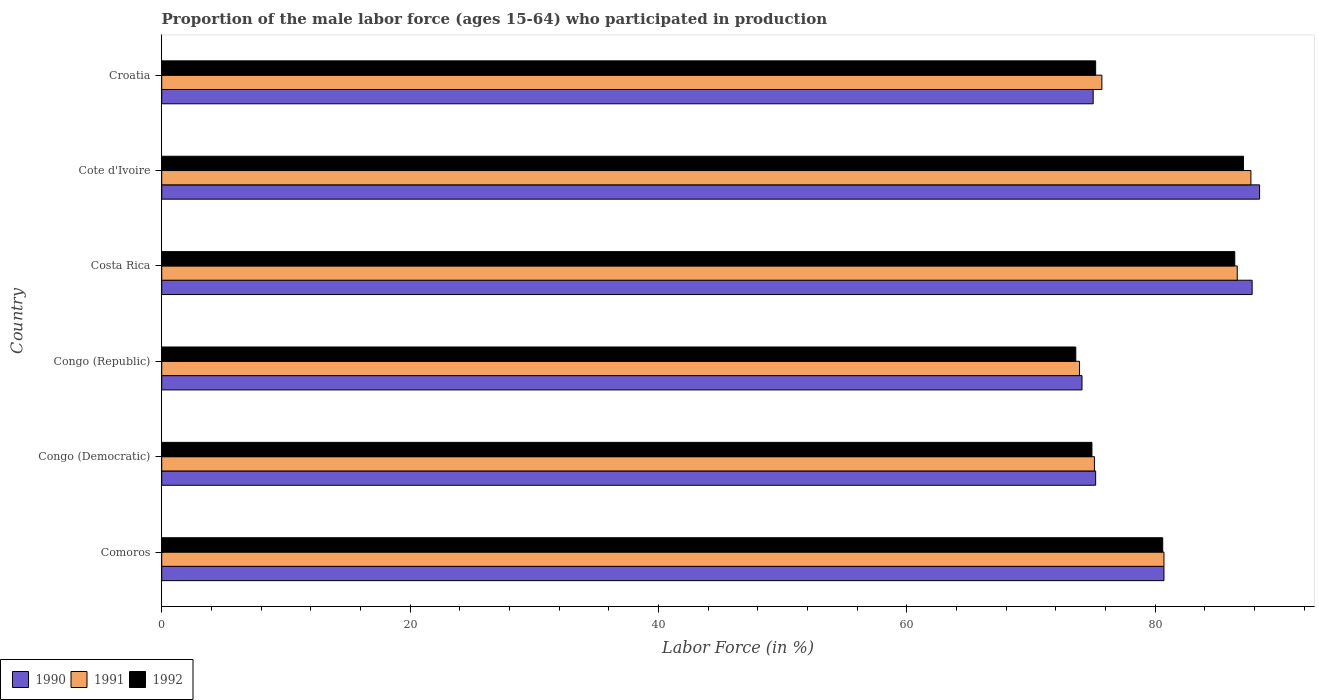How many different coloured bars are there?
Provide a short and direct response. 3. Are the number of bars per tick equal to the number of legend labels?
Provide a short and direct response. Yes. Are the number of bars on each tick of the Y-axis equal?
Give a very brief answer. Yes. How many bars are there on the 3rd tick from the bottom?
Give a very brief answer. 3. What is the label of the 1st group of bars from the top?
Provide a succinct answer. Croatia. What is the proportion of the male labor force who participated in production in 1990 in Costa Rica?
Offer a terse response. 87.8. Across all countries, what is the maximum proportion of the male labor force who participated in production in 1992?
Provide a succinct answer. 87.1. Across all countries, what is the minimum proportion of the male labor force who participated in production in 1991?
Make the answer very short. 73.9. In which country was the proportion of the male labor force who participated in production in 1991 maximum?
Ensure brevity in your answer.  Cote d'Ivoire. In which country was the proportion of the male labor force who participated in production in 1990 minimum?
Keep it short and to the point. Congo (Republic). What is the total proportion of the male labor force who participated in production in 1991 in the graph?
Ensure brevity in your answer.  479.7. What is the average proportion of the male labor force who participated in production in 1992 per country?
Your answer should be compact. 79.63. What is the difference between the proportion of the male labor force who participated in production in 1990 and proportion of the male labor force who participated in production in 1992 in Comoros?
Offer a terse response. 0.1. What is the ratio of the proportion of the male labor force who participated in production in 1992 in Congo (Democratic) to that in Croatia?
Ensure brevity in your answer.  1. Is the proportion of the male labor force who participated in production in 1992 in Congo (Democratic) less than that in Croatia?
Provide a succinct answer. Yes. Is the difference between the proportion of the male labor force who participated in production in 1990 in Cote d'Ivoire and Croatia greater than the difference between the proportion of the male labor force who participated in production in 1992 in Cote d'Ivoire and Croatia?
Your response must be concise. Yes. What is the difference between the highest and the second highest proportion of the male labor force who participated in production in 1992?
Your response must be concise. 0.7. What is the difference between the highest and the lowest proportion of the male labor force who participated in production in 1991?
Ensure brevity in your answer.  13.8. In how many countries, is the proportion of the male labor force who participated in production in 1991 greater than the average proportion of the male labor force who participated in production in 1991 taken over all countries?
Your answer should be compact. 3. Is the sum of the proportion of the male labor force who participated in production in 1992 in Comoros and Cote d'Ivoire greater than the maximum proportion of the male labor force who participated in production in 1991 across all countries?
Make the answer very short. Yes. How many bars are there?
Provide a short and direct response. 18. Are all the bars in the graph horizontal?
Offer a terse response. Yes. How many countries are there in the graph?
Give a very brief answer. 6. What is the difference between two consecutive major ticks on the X-axis?
Your answer should be compact. 20. Does the graph contain any zero values?
Keep it short and to the point. No. Where does the legend appear in the graph?
Offer a terse response. Bottom left. How many legend labels are there?
Give a very brief answer. 3. How are the legend labels stacked?
Provide a short and direct response. Horizontal. What is the title of the graph?
Ensure brevity in your answer.  Proportion of the male labor force (ages 15-64) who participated in production. What is the label or title of the X-axis?
Your answer should be compact. Labor Force (in %). What is the label or title of the Y-axis?
Your answer should be compact. Country. What is the Labor Force (in %) in 1990 in Comoros?
Provide a short and direct response. 80.7. What is the Labor Force (in %) of 1991 in Comoros?
Give a very brief answer. 80.7. What is the Labor Force (in %) in 1992 in Comoros?
Provide a short and direct response. 80.6. What is the Labor Force (in %) of 1990 in Congo (Democratic)?
Provide a succinct answer. 75.2. What is the Labor Force (in %) in 1991 in Congo (Democratic)?
Offer a terse response. 75.1. What is the Labor Force (in %) in 1992 in Congo (Democratic)?
Keep it short and to the point. 74.9. What is the Labor Force (in %) in 1990 in Congo (Republic)?
Your answer should be compact. 74.1. What is the Labor Force (in %) in 1991 in Congo (Republic)?
Keep it short and to the point. 73.9. What is the Labor Force (in %) in 1992 in Congo (Republic)?
Your response must be concise. 73.6. What is the Labor Force (in %) in 1990 in Costa Rica?
Your answer should be very brief. 87.8. What is the Labor Force (in %) in 1991 in Costa Rica?
Offer a terse response. 86.6. What is the Labor Force (in %) of 1992 in Costa Rica?
Offer a very short reply. 86.4. What is the Labor Force (in %) of 1990 in Cote d'Ivoire?
Keep it short and to the point. 88.4. What is the Labor Force (in %) in 1991 in Cote d'Ivoire?
Make the answer very short. 87.7. What is the Labor Force (in %) in 1992 in Cote d'Ivoire?
Your answer should be very brief. 87.1. What is the Labor Force (in %) of 1991 in Croatia?
Your answer should be compact. 75.7. What is the Labor Force (in %) of 1992 in Croatia?
Provide a short and direct response. 75.2. Across all countries, what is the maximum Labor Force (in %) of 1990?
Give a very brief answer. 88.4. Across all countries, what is the maximum Labor Force (in %) of 1991?
Offer a very short reply. 87.7. Across all countries, what is the maximum Labor Force (in %) in 1992?
Provide a short and direct response. 87.1. Across all countries, what is the minimum Labor Force (in %) of 1990?
Provide a short and direct response. 74.1. Across all countries, what is the minimum Labor Force (in %) of 1991?
Your response must be concise. 73.9. Across all countries, what is the minimum Labor Force (in %) of 1992?
Your response must be concise. 73.6. What is the total Labor Force (in %) of 1990 in the graph?
Make the answer very short. 481.2. What is the total Labor Force (in %) in 1991 in the graph?
Offer a terse response. 479.7. What is the total Labor Force (in %) of 1992 in the graph?
Give a very brief answer. 477.8. What is the difference between the Labor Force (in %) in 1992 in Comoros and that in Congo (Democratic)?
Offer a terse response. 5.7. What is the difference between the Labor Force (in %) in 1990 in Comoros and that in Congo (Republic)?
Offer a terse response. 6.6. What is the difference between the Labor Force (in %) of 1991 in Comoros and that in Costa Rica?
Your response must be concise. -5.9. What is the difference between the Labor Force (in %) in 1992 in Comoros and that in Costa Rica?
Give a very brief answer. -5.8. What is the difference between the Labor Force (in %) of 1991 in Comoros and that in Cote d'Ivoire?
Offer a terse response. -7. What is the difference between the Labor Force (in %) in 1990 in Comoros and that in Croatia?
Provide a succinct answer. 5.7. What is the difference between the Labor Force (in %) in 1991 in Comoros and that in Croatia?
Ensure brevity in your answer.  5. What is the difference between the Labor Force (in %) in 1991 in Congo (Democratic) and that in Congo (Republic)?
Your answer should be compact. 1.2. What is the difference between the Labor Force (in %) of 1992 in Congo (Democratic) and that in Costa Rica?
Ensure brevity in your answer.  -11.5. What is the difference between the Labor Force (in %) in 1991 in Congo (Democratic) and that in Cote d'Ivoire?
Provide a short and direct response. -12.6. What is the difference between the Labor Force (in %) of 1992 in Congo (Democratic) and that in Cote d'Ivoire?
Offer a very short reply. -12.2. What is the difference between the Labor Force (in %) in 1990 in Congo (Republic) and that in Costa Rica?
Offer a terse response. -13.7. What is the difference between the Labor Force (in %) of 1990 in Congo (Republic) and that in Cote d'Ivoire?
Make the answer very short. -14.3. What is the difference between the Labor Force (in %) of 1991 in Congo (Republic) and that in Cote d'Ivoire?
Your answer should be compact. -13.8. What is the difference between the Labor Force (in %) of 1992 in Congo (Republic) and that in Cote d'Ivoire?
Your response must be concise. -13.5. What is the difference between the Labor Force (in %) in 1990 in Congo (Republic) and that in Croatia?
Keep it short and to the point. -0.9. What is the difference between the Labor Force (in %) of 1991 in Congo (Republic) and that in Croatia?
Provide a short and direct response. -1.8. What is the difference between the Labor Force (in %) of 1991 in Costa Rica and that in Cote d'Ivoire?
Offer a very short reply. -1.1. What is the difference between the Labor Force (in %) in 1990 in Cote d'Ivoire and that in Croatia?
Your answer should be very brief. 13.4. What is the difference between the Labor Force (in %) of 1990 in Comoros and the Labor Force (in %) of 1992 in Congo (Democratic)?
Make the answer very short. 5.8. What is the difference between the Labor Force (in %) in 1991 in Comoros and the Labor Force (in %) in 1992 in Congo (Democratic)?
Offer a terse response. 5.8. What is the difference between the Labor Force (in %) in 1990 in Comoros and the Labor Force (in %) in 1991 in Congo (Republic)?
Keep it short and to the point. 6.8. What is the difference between the Labor Force (in %) of 1991 in Comoros and the Labor Force (in %) of 1992 in Congo (Republic)?
Your response must be concise. 7.1. What is the difference between the Labor Force (in %) of 1990 in Comoros and the Labor Force (in %) of 1992 in Costa Rica?
Keep it short and to the point. -5.7. What is the difference between the Labor Force (in %) of 1990 in Comoros and the Labor Force (in %) of 1991 in Cote d'Ivoire?
Your answer should be compact. -7. What is the difference between the Labor Force (in %) of 1990 in Comoros and the Labor Force (in %) of 1992 in Cote d'Ivoire?
Give a very brief answer. -6.4. What is the difference between the Labor Force (in %) in 1990 in Comoros and the Labor Force (in %) in 1992 in Croatia?
Provide a short and direct response. 5.5. What is the difference between the Labor Force (in %) of 1991 in Comoros and the Labor Force (in %) of 1992 in Croatia?
Offer a terse response. 5.5. What is the difference between the Labor Force (in %) in 1990 in Congo (Democratic) and the Labor Force (in %) in 1991 in Congo (Republic)?
Ensure brevity in your answer.  1.3. What is the difference between the Labor Force (in %) in 1990 in Congo (Democratic) and the Labor Force (in %) in 1992 in Congo (Republic)?
Ensure brevity in your answer.  1.6. What is the difference between the Labor Force (in %) in 1991 in Congo (Democratic) and the Labor Force (in %) in 1992 in Congo (Republic)?
Give a very brief answer. 1.5. What is the difference between the Labor Force (in %) of 1990 in Congo (Democratic) and the Labor Force (in %) of 1991 in Costa Rica?
Provide a succinct answer. -11.4. What is the difference between the Labor Force (in %) of 1990 in Congo (Democratic) and the Labor Force (in %) of 1991 in Cote d'Ivoire?
Your answer should be compact. -12.5. What is the difference between the Labor Force (in %) of 1991 in Congo (Democratic) and the Labor Force (in %) of 1992 in Cote d'Ivoire?
Your answer should be very brief. -12. What is the difference between the Labor Force (in %) in 1990 in Congo (Democratic) and the Labor Force (in %) in 1991 in Croatia?
Your response must be concise. -0.5. What is the difference between the Labor Force (in %) of 1990 in Congo (Republic) and the Labor Force (in %) of 1992 in Costa Rica?
Provide a short and direct response. -12.3. What is the difference between the Labor Force (in %) of 1990 in Congo (Republic) and the Labor Force (in %) of 1992 in Cote d'Ivoire?
Offer a terse response. -13. What is the difference between the Labor Force (in %) in 1991 in Congo (Republic) and the Labor Force (in %) in 1992 in Cote d'Ivoire?
Make the answer very short. -13.2. What is the difference between the Labor Force (in %) of 1990 in Congo (Republic) and the Labor Force (in %) of 1991 in Croatia?
Offer a very short reply. -1.6. What is the difference between the Labor Force (in %) of 1991 in Congo (Republic) and the Labor Force (in %) of 1992 in Croatia?
Make the answer very short. -1.3. What is the difference between the Labor Force (in %) in 1990 in Costa Rica and the Labor Force (in %) in 1992 in Cote d'Ivoire?
Your response must be concise. 0.7. What is the difference between the Labor Force (in %) of 1991 in Costa Rica and the Labor Force (in %) of 1992 in Cote d'Ivoire?
Make the answer very short. -0.5. What is the difference between the Labor Force (in %) in 1990 in Costa Rica and the Labor Force (in %) in 1991 in Croatia?
Offer a terse response. 12.1. What is the difference between the Labor Force (in %) of 1991 in Costa Rica and the Labor Force (in %) of 1992 in Croatia?
Your answer should be very brief. 11.4. What is the difference between the Labor Force (in %) in 1990 in Cote d'Ivoire and the Labor Force (in %) in 1992 in Croatia?
Ensure brevity in your answer.  13.2. What is the average Labor Force (in %) in 1990 per country?
Provide a short and direct response. 80.2. What is the average Labor Force (in %) in 1991 per country?
Your response must be concise. 79.95. What is the average Labor Force (in %) in 1992 per country?
Your answer should be compact. 79.63. What is the difference between the Labor Force (in %) of 1990 and Labor Force (in %) of 1991 in Comoros?
Provide a succinct answer. 0. What is the difference between the Labor Force (in %) in 1990 and Labor Force (in %) in 1992 in Comoros?
Offer a very short reply. 0.1. What is the difference between the Labor Force (in %) in 1990 and Labor Force (in %) in 1991 in Congo (Democratic)?
Keep it short and to the point. 0.1. What is the difference between the Labor Force (in %) in 1990 and Labor Force (in %) in 1992 in Congo (Democratic)?
Give a very brief answer. 0.3. What is the difference between the Labor Force (in %) in 1990 and Labor Force (in %) in 1991 in Congo (Republic)?
Your answer should be very brief. 0.2. What is the difference between the Labor Force (in %) in 1990 and Labor Force (in %) in 1992 in Congo (Republic)?
Ensure brevity in your answer.  0.5. What is the difference between the Labor Force (in %) in 1991 and Labor Force (in %) in 1992 in Congo (Republic)?
Provide a short and direct response. 0.3. What is the difference between the Labor Force (in %) in 1990 and Labor Force (in %) in 1992 in Costa Rica?
Give a very brief answer. 1.4. What is the difference between the Labor Force (in %) in 1990 and Labor Force (in %) in 1992 in Cote d'Ivoire?
Offer a terse response. 1.3. What is the difference between the Labor Force (in %) in 1991 and Labor Force (in %) in 1992 in Cote d'Ivoire?
Your answer should be compact. 0.6. What is the difference between the Labor Force (in %) in 1991 and Labor Force (in %) in 1992 in Croatia?
Make the answer very short. 0.5. What is the ratio of the Labor Force (in %) of 1990 in Comoros to that in Congo (Democratic)?
Provide a short and direct response. 1.07. What is the ratio of the Labor Force (in %) in 1991 in Comoros to that in Congo (Democratic)?
Offer a very short reply. 1.07. What is the ratio of the Labor Force (in %) of 1992 in Comoros to that in Congo (Democratic)?
Keep it short and to the point. 1.08. What is the ratio of the Labor Force (in %) of 1990 in Comoros to that in Congo (Republic)?
Provide a succinct answer. 1.09. What is the ratio of the Labor Force (in %) of 1991 in Comoros to that in Congo (Republic)?
Offer a terse response. 1.09. What is the ratio of the Labor Force (in %) of 1992 in Comoros to that in Congo (Republic)?
Provide a succinct answer. 1.1. What is the ratio of the Labor Force (in %) of 1990 in Comoros to that in Costa Rica?
Keep it short and to the point. 0.92. What is the ratio of the Labor Force (in %) in 1991 in Comoros to that in Costa Rica?
Your answer should be compact. 0.93. What is the ratio of the Labor Force (in %) of 1992 in Comoros to that in Costa Rica?
Give a very brief answer. 0.93. What is the ratio of the Labor Force (in %) in 1990 in Comoros to that in Cote d'Ivoire?
Keep it short and to the point. 0.91. What is the ratio of the Labor Force (in %) of 1991 in Comoros to that in Cote d'Ivoire?
Make the answer very short. 0.92. What is the ratio of the Labor Force (in %) of 1992 in Comoros to that in Cote d'Ivoire?
Keep it short and to the point. 0.93. What is the ratio of the Labor Force (in %) in 1990 in Comoros to that in Croatia?
Offer a very short reply. 1.08. What is the ratio of the Labor Force (in %) in 1991 in Comoros to that in Croatia?
Provide a succinct answer. 1.07. What is the ratio of the Labor Force (in %) of 1992 in Comoros to that in Croatia?
Your answer should be compact. 1.07. What is the ratio of the Labor Force (in %) in 1990 in Congo (Democratic) to that in Congo (Republic)?
Your answer should be compact. 1.01. What is the ratio of the Labor Force (in %) of 1991 in Congo (Democratic) to that in Congo (Republic)?
Provide a short and direct response. 1.02. What is the ratio of the Labor Force (in %) of 1992 in Congo (Democratic) to that in Congo (Republic)?
Make the answer very short. 1.02. What is the ratio of the Labor Force (in %) in 1990 in Congo (Democratic) to that in Costa Rica?
Your response must be concise. 0.86. What is the ratio of the Labor Force (in %) in 1991 in Congo (Democratic) to that in Costa Rica?
Your answer should be compact. 0.87. What is the ratio of the Labor Force (in %) of 1992 in Congo (Democratic) to that in Costa Rica?
Give a very brief answer. 0.87. What is the ratio of the Labor Force (in %) of 1990 in Congo (Democratic) to that in Cote d'Ivoire?
Your answer should be compact. 0.85. What is the ratio of the Labor Force (in %) of 1991 in Congo (Democratic) to that in Cote d'Ivoire?
Keep it short and to the point. 0.86. What is the ratio of the Labor Force (in %) of 1992 in Congo (Democratic) to that in Cote d'Ivoire?
Ensure brevity in your answer.  0.86. What is the ratio of the Labor Force (in %) in 1991 in Congo (Democratic) to that in Croatia?
Give a very brief answer. 0.99. What is the ratio of the Labor Force (in %) of 1990 in Congo (Republic) to that in Costa Rica?
Your answer should be very brief. 0.84. What is the ratio of the Labor Force (in %) of 1991 in Congo (Republic) to that in Costa Rica?
Give a very brief answer. 0.85. What is the ratio of the Labor Force (in %) of 1992 in Congo (Republic) to that in Costa Rica?
Provide a succinct answer. 0.85. What is the ratio of the Labor Force (in %) of 1990 in Congo (Republic) to that in Cote d'Ivoire?
Provide a short and direct response. 0.84. What is the ratio of the Labor Force (in %) of 1991 in Congo (Republic) to that in Cote d'Ivoire?
Ensure brevity in your answer.  0.84. What is the ratio of the Labor Force (in %) of 1992 in Congo (Republic) to that in Cote d'Ivoire?
Your response must be concise. 0.84. What is the ratio of the Labor Force (in %) in 1991 in Congo (Republic) to that in Croatia?
Offer a very short reply. 0.98. What is the ratio of the Labor Force (in %) of 1992 in Congo (Republic) to that in Croatia?
Ensure brevity in your answer.  0.98. What is the ratio of the Labor Force (in %) in 1990 in Costa Rica to that in Cote d'Ivoire?
Your answer should be compact. 0.99. What is the ratio of the Labor Force (in %) of 1991 in Costa Rica to that in Cote d'Ivoire?
Offer a very short reply. 0.99. What is the ratio of the Labor Force (in %) in 1992 in Costa Rica to that in Cote d'Ivoire?
Provide a succinct answer. 0.99. What is the ratio of the Labor Force (in %) of 1990 in Costa Rica to that in Croatia?
Make the answer very short. 1.17. What is the ratio of the Labor Force (in %) in 1991 in Costa Rica to that in Croatia?
Give a very brief answer. 1.14. What is the ratio of the Labor Force (in %) of 1992 in Costa Rica to that in Croatia?
Your response must be concise. 1.15. What is the ratio of the Labor Force (in %) in 1990 in Cote d'Ivoire to that in Croatia?
Keep it short and to the point. 1.18. What is the ratio of the Labor Force (in %) of 1991 in Cote d'Ivoire to that in Croatia?
Provide a short and direct response. 1.16. What is the ratio of the Labor Force (in %) in 1992 in Cote d'Ivoire to that in Croatia?
Give a very brief answer. 1.16. What is the difference between the highest and the second highest Labor Force (in %) of 1990?
Your response must be concise. 0.6. What is the difference between the highest and the second highest Labor Force (in %) of 1992?
Provide a short and direct response. 0.7. What is the difference between the highest and the lowest Labor Force (in %) in 1992?
Provide a succinct answer. 13.5. 